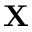Convert formula to latex. <formula><loc_0><loc_0><loc_500><loc_500>X</formula> 